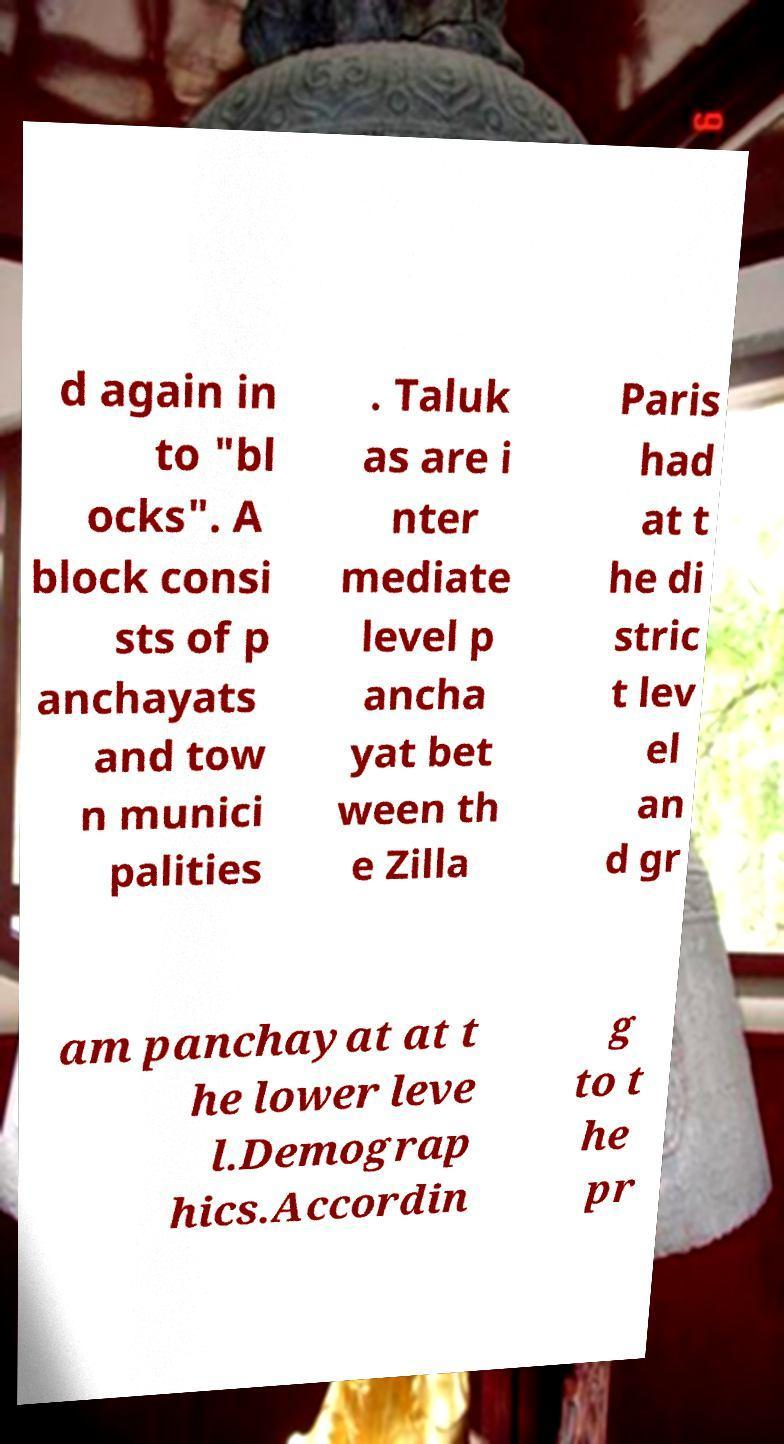Can you read and provide the text displayed in the image?This photo seems to have some interesting text. Can you extract and type it out for me? d again in to "bl ocks". A block consi sts of p anchayats and tow n munici palities . Taluk as are i nter mediate level p ancha yat bet ween th e Zilla Paris had at t he di stric t lev el an d gr am panchayat at t he lower leve l.Demograp hics.Accordin g to t he pr 